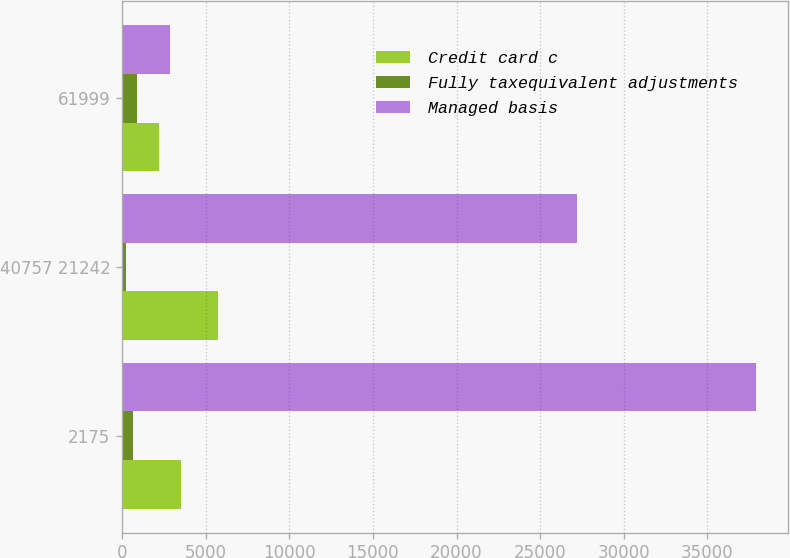Convert chart to OTSL. <chart><loc_0><loc_0><loc_500><loc_500><stacked_bar_chart><ecel><fcel>2175<fcel>40757 21242<fcel>61999<nl><fcel>Credit card c<fcel>3509<fcel>5719<fcel>2210<nl><fcel>Fully taxequivalent adjustments<fcel>676<fcel>228<fcel>904<nl><fcel>Managed basis<fcel>37924<fcel>27189<fcel>2859.5<nl></chart> 